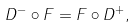<formula> <loc_0><loc_0><loc_500><loc_500>D ^ { - } \circ F = F \circ D ^ { + } ,</formula> 